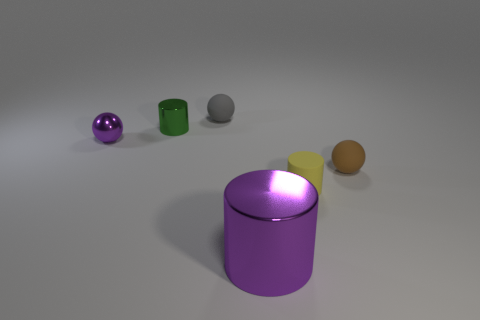Is the material of the purple thing that is left of the tiny green cylinder the same as the cylinder that is to the left of the big purple thing?
Provide a succinct answer. Yes. What is the shape of the small metallic thing that is the same color as the large metal object?
Offer a very short reply. Sphere. How many objects are objects that are to the left of the purple cylinder or metal things right of the tiny green metallic thing?
Provide a short and direct response. 4. There is a tiny shiny object that is to the left of the green metal cylinder; is its color the same as the metallic thing that is on the right side of the small gray rubber sphere?
Keep it short and to the point. Yes. What shape is the small rubber object that is to the left of the small brown rubber thing and in front of the gray matte sphere?
Your answer should be very brief. Cylinder. What is the color of the shiny cylinder that is the same size as the purple ball?
Your response must be concise. Green. Is there a matte ball that has the same color as the large shiny thing?
Provide a short and direct response. No. There is a cylinder that is in front of the yellow rubber cylinder; does it have the same size as the brown matte sphere behind the tiny rubber cylinder?
Keep it short and to the point. No. There is a sphere that is both left of the brown rubber sphere and in front of the small metallic cylinder; what is its material?
Your response must be concise. Metal. There is a metallic thing that is the same color as the big metal cylinder; what size is it?
Make the answer very short. Small. 